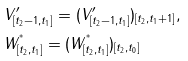<formula> <loc_0><loc_0><loc_500><loc_500>& V _ { [ t _ { 2 } - 1 , t _ { 1 } ] } ^ { \prime } = ( V _ { [ t _ { 2 } - 1 , t _ { 1 } ] } ^ { \prime } ) _ { [ t _ { 2 } , t _ { 1 } + 1 ] } , \\ & W _ { [ t _ { 2 } , t _ { 1 } ] } ^ { ^ { * } } = ( W _ { [ t _ { 2 } , t _ { 1 } ] } ^ { ^ { * } } ) _ { [ t _ { 2 } , t _ { 0 } ] }</formula> 